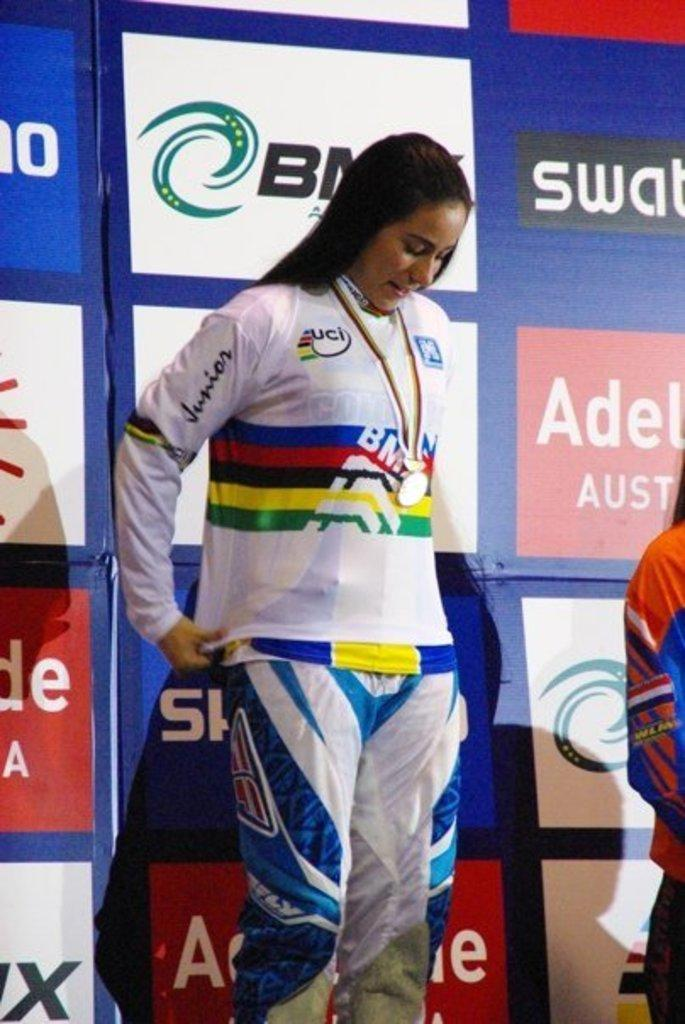Provide a one-sentence caption for the provided image. Woman in sports wear standing behind advertising board with Aus to her right. 